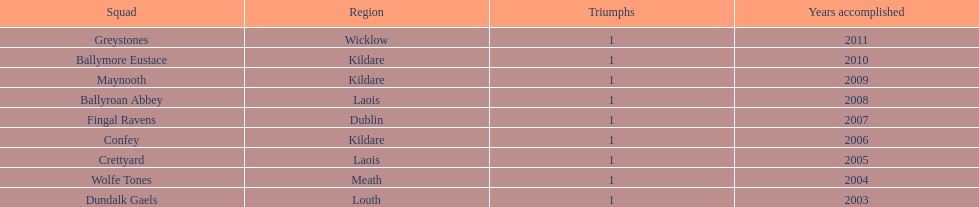What is the number of wins for greystones? 1. 